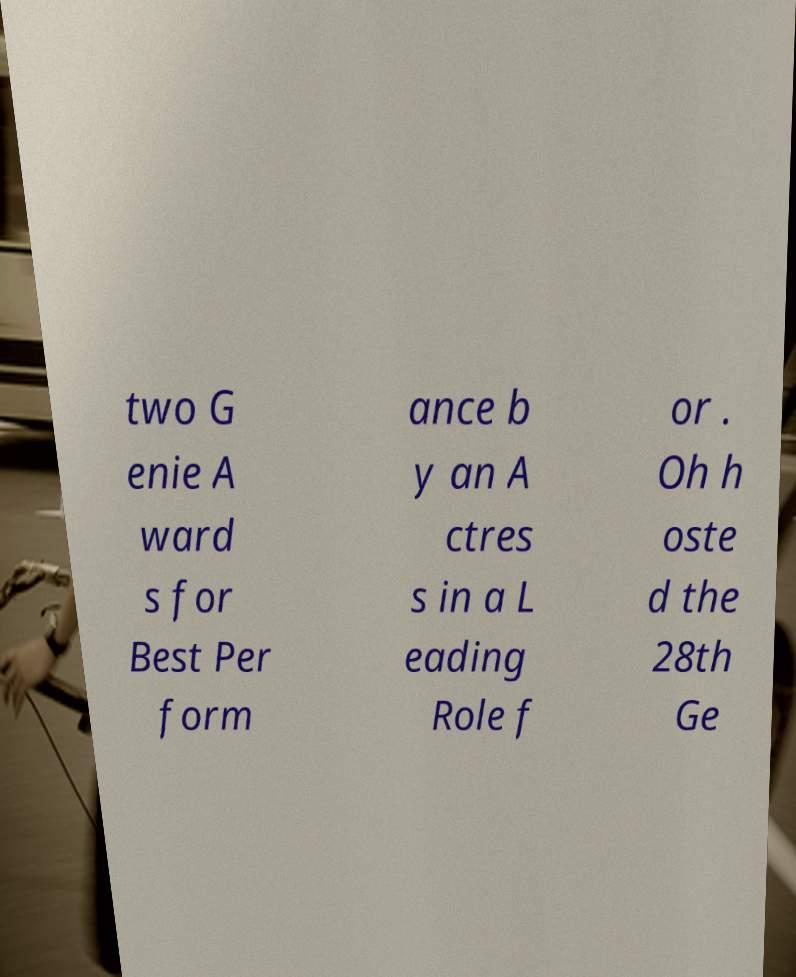Can you accurately transcribe the text from the provided image for me? two G enie A ward s for Best Per form ance b y an A ctres s in a L eading Role f or . Oh h oste d the 28th Ge 